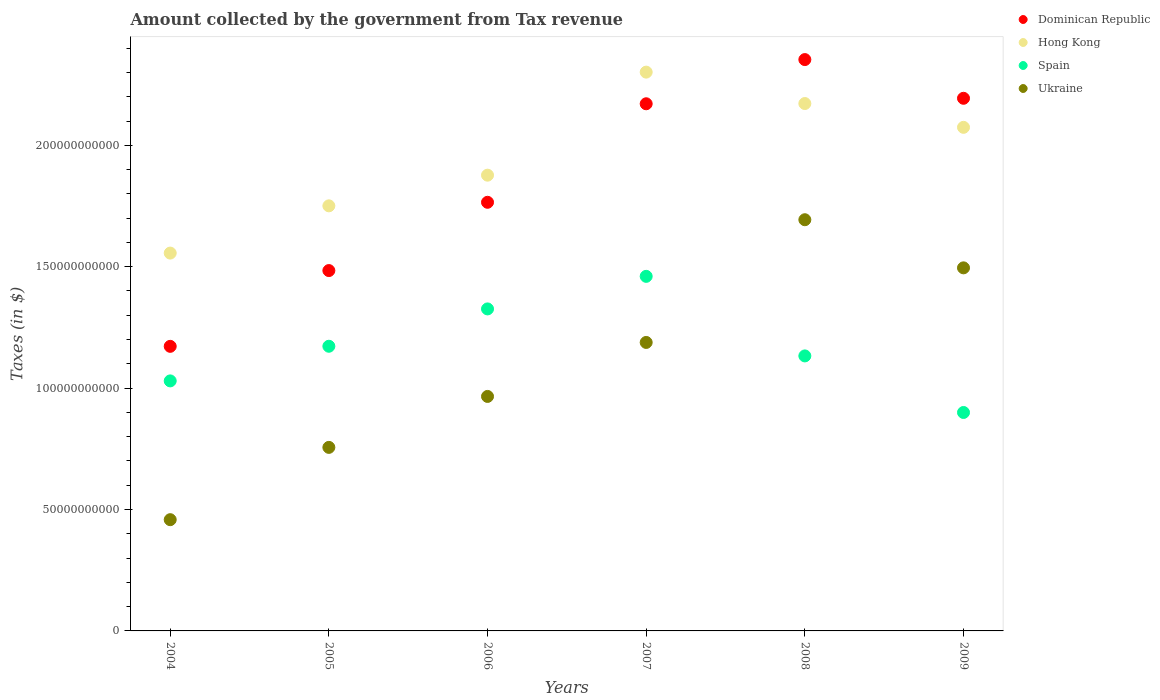How many different coloured dotlines are there?
Give a very brief answer. 4. Is the number of dotlines equal to the number of legend labels?
Your answer should be very brief. Yes. What is the amount collected by the government from tax revenue in Ukraine in 2004?
Give a very brief answer. 4.58e+1. Across all years, what is the maximum amount collected by the government from tax revenue in Ukraine?
Provide a short and direct response. 1.69e+11. Across all years, what is the minimum amount collected by the government from tax revenue in Hong Kong?
Ensure brevity in your answer.  1.56e+11. In which year was the amount collected by the government from tax revenue in Spain maximum?
Your response must be concise. 2007. In which year was the amount collected by the government from tax revenue in Spain minimum?
Provide a short and direct response. 2009. What is the total amount collected by the government from tax revenue in Dominican Republic in the graph?
Keep it short and to the point. 1.11e+12. What is the difference between the amount collected by the government from tax revenue in Hong Kong in 2005 and that in 2007?
Provide a short and direct response. -5.51e+1. What is the difference between the amount collected by the government from tax revenue in Spain in 2004 and the amount collected by the government from tax revenue in Dominican Republic in 2005?
Your answer should be compact. -4.54e+1. What is the average amount collected by the government from tax revenue in Ukraine per year?
Give a very brief answer. 1.09e+11. In the year 2008, what is the difference between the amount collected by the government from tax revenue in Hong Kong and amount collected by the government from tax revenue in Spain?
Keep it short and to the point. 1.04e+11. What is the ratio of the amount collected by the government from tax revenue in Spain in 2005 to that in 2009?
Give a very brief answer. 1.3. Is the difference between the amount collected by the government from tax revenue in Hong Kong in 2004 and 2005 greater than the difference between the amount collected by the government from tax revenue in Spain in 2004 and 2005?
Ensure brevity in your answer.  No. What is the difference between the highest and the second highest amount collected by the government from tax revenue in Hong Kong?
Offer a terse response. 1.29e+1. What is the difference between the highest and the lowest amount collected by the government from tax revenue in Hong Kong?
Offer a very short reply. 7.45e+1. Does the amount collected by the government from tax revenue in Dominican Republic monotonically increase over the years?
Offer a very short reply. No. Is the amount collected by the government from tax revenue in Spain strictly greater than the amount collected by the government from tax revenue in Dominican Republic over the years?
Provide a short and direct response. No. How many dotlines are there?
Keep it short and to the point. 4. Does the graph contain any zero values?
Keep it short and to the point. No. Where does the legend appear in the graph?
Ensure brevity in your answer.  Top right. How are the legend labels stacked?
Ensure brevity in your answer.  Vertical. What is the title of the graph?
Provide a short and direct response. Amount collected by the government from Tax revenue. What is the label or title of the Y-axis?
Your answer should be very brief. Taxes (in $). What is the Taxes (in $) of Dominican Republic in 2004?
Ensure brevity in your answer.  1.17e+11. What is the Taxes (in $) in Hong Kong in 2004?
Keep it short and to the point. 1.56e+11. What is the Taxes (in $) of Spain in 2004?
Your response must be concise. 1.03e+11. What is the Taxes (in $) in Ukraine in 2004?
Give a very brief answer. 4.58e+1. What is the Taxes (in $) of Dominican Republic in 2005?
Keep it short and to the point. 1.48e+11. What is the Taxes (in $) in Hong Kong in 2005?
Offer a terse response. 1.75e+11. What is the Taxes (in $) of Spain in 2005?
Provide a short and direct response. 1.17e+11. What is the Taxes (in $) in Ukraine in 2005?
Your answer should be compact. 7.56e+1. What is the Taxes (in $) of Dominican Republic in 2006?
Your response must be concise. 1.77e+11. What is the Taxes (in $) in Hong Kong in 2006?
Ensure brevity in your answer.  1.88e+11. What is the Taxes (in $) in Spain in 2006?
Offer a terse response. 1.33e+11. What is the Taxes (in $) of Ukraine in 2006?
Your answer should be very brief. 9.66e+1. What is the Taxes (in $) of Dominican Republic in 2007?
Give a very brief answer. 2.17e+11. What is the Taxes (in $) of Hong Kong in 2007?
Offer a terse response. 2.30e+11. What is the Taxes (in $) of Spain in 2007?
Offer a very short reply. 1.46e+11. What is the Taxes (in $) in Ukraine in 2007?
Offer a terse response. 1.19e+11. What is the Taxes (in $) in Dominican Republic in 2008?
Make the answer very short. 2.35e+11. What is the Taxes (in $) in Hong Kong in 2008?
Ensure brevity in your answer.  2.17e+11. What is the Taxes (in $) in Spain in 2008?
Your answer should be compact. 1.13e+11. What is the Taxes (in $) of Ukraine in 2008?
Give a very brief answer. 1.69e+11. What is the Taxes (in $) of Dominican Republic in 2009?
Your response must be concise. 2.19e+11. What is the Taxes (in $) in Hong Kong in 2009?
Keep it short and to the point. 2.07e+11. What is the Taxes (in $) of Spain in 2009?
Ensure brevity in your answer.  9.00e+1. What is the Taxes (in $) of Ukraine in 2009?
Ensure brevity in your answer.  1.50e+11. Across all years, what is the maximum Taxes (in $) in Dominican Republic?
Your response must be concise. 2.35e+11. Across all years, what is the maximum Taxes (in $) of Hong Kong?
Your response must be concise. 2.30e+11. Across all years, what is the maximum Taxes (in $) in Spain?
Your answer should be compact. 1.46e+11. Across all years, what is the maximum Taxes (in $) of Ukraine?
Provide a succinct answer. 1.69e+11. Across all years, what is the minimum Taxes (in $) of Dominican Republic?
Make the answer very short. 1.17e+11. Across all years, what is the minimum Taxes (in $) of Hong Kong?
Provide a succinct answer. 1.56e+11. Across all years, what is the minimum Taxes (in $) of Spain?
Keep it short and to the point. 9.00e+1. Across all years, what is the minimum Taxes (in $) of Ukraine?
Offer a very short reply. 4.58e+1. What is the total Taxes (in $) in Dominican Republic in the graph?
Provide a short and direct response. 1.11e+12. What is the total Taxes (in $) in Hong Kong in the graph?
Offer a terse response. 1.17e+12. What is the total Taxes (in $) in Spain in the graph?
Keep it short and to the point. 7.02e+11. What is the total Taxes (in $) of Ukraine in the graph?
Offer a very short reply. 6.56e+11. What is the difference between the Taxes (in $) in Dominican Republic in 2004 and that in 2005?
Ensure brevity in your answer.  -3.12e+1. What is the difference between the Taxes (in $) of Hong Kong in 2004 and that in 2005?
Give a very brief answer. -1.95e+1. What is the difference between the Taxes (in $) of Spain in 2004 and that in 2005?
Provide a short and direct response. -1.43e+1. What is the difference between the Taxes (in $) in Ukraine in 2004 and that in 2005?
Offer a very short reply. -2.98e+1. What is the difference between the Taxes (in $) in Dominican Republic in 2004 and that in 2006?
Make the answer very short. -5.93e+1. What is the difference between the Taxes (in $) of Hong Kong in 2004 and that in 2006?
Provide a succinct answer. -3.21e+1. What is the difference between the Taxes (in $) in Spain in 2004 and that in 2006?
Give a very brief answer. -2.96e+1. What is the difference between the Taxes (in $) in Ukraine in 2004 and that in 2006?
Offer a terse response. -5.08e+1. What is the difference between the Taxes (in $) in Dominican Republic in 2004 and that in 2007?
Provide a succinct answer. -9.99e+1. What is the difference between the Taxes (in $) of Hong Kong in 2004 and that in 2007?
Offer a terse response. -7.45e+1. What is the difference between the Taxes (in $) in Spain in 2004 and that in 2007?
Offer a very short reply. -4.31e+1. What is the difference between the Taxes (in $) of Ukraine in 2004 and that in 2007?
Your response must be concise. -7.30e+1. What is the difference between the Taxes (in $) in Dominican Republic in 2004 and that in 2008?
Provide a succinct answer. -1.18e+11. What is the difference between the Taxes (in $) in Hong Kong in 2004 and that in 2008?
Give a very brief answer. -6.16e+1. What is the difference between the Taxes (in $) of Spain in 2004 and that in 2008?
Your response must be concise. -1.03e+1. What is the difference between the Taxes (in $) in Ukraine in 2004 and that in 2008?
Your answer should be very brief. -1.24e+11. What is the difference between the Taxes (in $) of Dominican Republic in 2004 and that in 2009?
Ensure brevity in your answer.  -1.02e+11. What is the difference between the Taxes (in $) of Hong Kong in 2004 and that in 2009?
Your answer should be compact. -5.18e+1. What is the difference between the Taxes (in $) in Spain in 2004 and that in 2009?
Your answer should be compact. 1.30e+1. What is the difference between the Taxes (in $) in Ukraine in 2004 and that in 2009?
Keep it short and to the point. -1.04e+11. What is the difference between the Taxes (in $) of Dominican Republic in 2005 and that in 2006?
Offer a very short reply. -2.81e+1. What is the difference between the Taxes (in $) in Hong Kong in 2005 and that in 2006?
Make the answer very short. -1.26e+1. What is the difference between the Taxes (in $) of Spain in 2005 and that in 2006?
Provide a short and direct response. -1.54e+1. What is the difference between the Taxes (in $) in Ukraine in 2005 and that in 2006?
Offer a very short reply. -2.10e+1. What is the difference between the Taxes (in $) of Dominican Republic in 2005 and that in 2007?
Your response must be concise. -6.87e+1. What is the difference between the Taxes (in $) in Hong Kong in 2005 and that in 2007?
Give a very brief answer. -5.51e+1. What is the difference between the Taxes (in $) of Spain in 2005 and that in 2007?
Ensure brevity in your answer.  -2.88e+1. What is the difference between the Taxes (in $) in Ukraine in 2005 and that in 2007?
Ensure brevity in your answer.  -4.32e+1. What is the difference between the Taxes (in $) of Dominican Republic in 2005 and that in 2008?
Offer a terse response. -8.69e+1. What is the difference between the Taxes (in $) of Hong Kong in 2005 and that in 2008?
Offer a terse response. -4.21e+1. What is the difference between the Taxes (in $) of Spain in 2005 and that in 2008?
Provide a short and direct response. 3.98e+09. What is the difference between the Taxes (in $) of Ukraine in 2005 and that in 2008?
Your answer should be compact. -9.38e+1. What is the difference between the Taxes (in $) of Dominican Republic in 2005 and that in 2009?
Ensure brevity in your answer.  -7.10e+1. What is the difference between the Taxes (in $) in Hong Kong in 2005 and that in 2009?
Make the answer very short. -3.23e+1. What is the difference between the Taxes (in $) of Spain in 2005 and that in 2009?
Give a very brief answer. 2.73e+1. What is the difference between the Taxes (in $) in Ukraine in 2005 and that in 2009?
Offer a very short reply. -7.39e+1. What is the difference between the Taxes (in $) of Dominican Republic in 2006 and that in 2007?
Give a very brief answer. -4.06e+1. What is the difference between the Taxes (in $) in Hong Kong in 2006 and that in 2007?
Offer a terse response. -4.24e+1. What is the difference between the Taxes (in $) in Spain in 2006 and that in 2007?
Your answer should be very brief. -1.34e+1. What is the difference between the Taxes (in $) of Ukraine in 2006 and that in 2007?
Make the answer very short. -2.22e+1. What is the difference between the Taxes (in $) of Dominican Republic in 2006 and that in 2008?
Provide a short and direct response. -5.88e+1. What is the difference between the Taxes (in $) of Hong Kong in 2006 and that in 2008?
Your answer should be compact. -2.95e+1. What is the difference between the Taxes (in $) of Spain in 2006 and that in 2008?
Provide a short and direct response. 1.94e+1. What is the difference between the Taxes (in $) in Ukraine in 2006 and that in 2008?
Your answer should be compact. -7.28e+1. What is the difference between the Taxes (in $) of Dominican Republic in 2006 and that in 2009?
Offer a very short reply. -4.28e+1. What is the difference between the Taxes (in $) of Hong Kong in 2006 and that in 2009?
Your answer should be compact. -1.97e+1. What is the difference between the Taxes (in $) in Spain in 2006 and that in 2009?
Keep it short and to the point. 4.27e+1. What is the difference between the Taxes (in $) of Ukraine in 2006 and that in 2009?
Your answer should be very brief. -5.30e+1. What is the difference between the Taxes (in $) of Dominican Republic in 2007 and that in 2008?
Your response must be concise. -1.82e+1. What is the difference between the Taxes (in $) in Hong Kong in 2007 and that in 2008?
Offer a terse response. 1.29e+1. What is the difference between the Taxes (in $) of Spain in 2007 and that in 2008?
Offer a terse response. 3.28e+1. What is the difference between the Taxes (in $) in Ukraine in 2007 and that in 2008?
Your answer should be very brief. -5.05e+1. What is the difference between the Taxes (in $) of Dominican Republic in 2007 and that in 2009?
Give a very brief answer. -2.26e+09. What is the difference between the Taxes (in $) in Hong Kong in 2007 and that in 2009?
Offer a very short reply. 2.27e+1. What is the difference between the Taxes (in $) in Spain in 2007 and that in 2009?
Provide a short and direct response. 5.61e+1. What is the difference between the Taxes (in $) in Ukraine in 2007 and that in 2009?
Make the answer very short. -3.07e+1. What is the difference between the Taxes (in $) in Dominican Republic in 2008 and that in 2009?
Your answer should be very brief. 1.59e+1. What is the difference between the Taxes (in $) in Hong Kong in 2008 and that in 2009?
Keep it short and to the point. 9.80e+09. What is the difference between the Taxes (in $) of Spain in 2008 and that in 2009?
Offer a terse response. 2.33e+1. What is the difference between the Taxes (in $) of Ukraine in 2008 and that in 2009?
Make the answer very short. 1.98e+1. What is the difference between the Taxes (in $) in Dominican Republic in 2004 and the Taxes (in $) in Hong Kong in 2005?
Your answer should be very brief. -5.79e+1. What is the difference between the Taxes (in $) in Dominican Republic in 2004 and the Taxes (in $) in Spain in 2005?
Your response must be concise. -3.61e+07. What is the difference between the Taxes (in $) of Dominican Republic in 2004 and the Taxes (in $) of Ukraine in 2005?
Your answer should be very brief. 4.16e+1. What is the difference between the Taxes (in $) of Hong Kong in 2004 and the Taxes (in $) of Spain in 2005?
Offer a very short reply. 3.84e+1. What is the difference between the Taxes (in $) of Hong Kong in 2004 and the Taxes (in $) of Ukraine in 2005?
Ensure brevity in your answer.  8.00e+1. What is the difference between the Taxes (in $) in Spain in 2004 and the Taxes (in $) in Ukraine in 2005?
Keep it short and to the point. 2.74e+1. What is the difference between the Taxes (in $) of Dominican Republic in 2004 and the Taxes (in $) of Hong Kong in 2006?
Offer a terse response. -7.05e+1. What is the difference between the Taxes (in $) of Dominican Republic in 2004 and the Taxes (in $) of Spain in 2006?
Your answer should be compact. -1.54e+1. What is the difference between the Taxes (in $) in Dominican Republic in 2004 and the Taxes (in $) in Ukraine in 2006?
Your answer should be compact. 2.06e+1. What is the difference between the Taxes (in $) of Hong Kong in 2004 and the Taxes (in $) of Spain in 2006?
Keep it short and to the point. 2.30e+1. What is the difference between the Taxes (in $) in Hong Kong in 2004 and the Taxes (in $) in Ukraine in 2006?
Provide a succinct answer. 5.90e+1. What is the difference between the Taxes (in $) of Spain in 2004 and the Taxes (in $) of Ukraine in 2006?
Ensure brevity in your answer.  6.40e+09. What is the difference between the Taxes (in $) in Dominican Republic in 2004 and the Taxes (in $) in Hong Kong in 2007?
Ensure brevity in your answer.  -1.13e+11. What is the difference between the Taxes (in $) of Dominican Republic in 2004 and the Taxes (in $) of Spain in 2007?
Ensure brevity in your answer.  -2.88e+1. What is the difference between the Taxes (in $) of Dominican Republic in 2004 and the Taxes (in $) of Ukraine in 2007?
Keep it short and to the point. -1.61e+09. What is the difference between the Taxes (in $) in Hong Kong in 2004 and the Taxes (in $) in Spain in 2007?
Your answer should be very brief. 9.58e+09. What is the difference between the Taxes (in $) of Hong Kong in 2004 and the Taxes (in $) of Ukraine in 2007?
Ensure brevity in your answer.  3.68e+1. What is the difference between the Taxes (in $) in Spain in 2004 and the Taxes (in $) in Ukraine in 2007?
Ensure brevity in your answer.  -1.58e+1. What is the difference between the Taxes (in $) of Dominican Republic in 2004 and the Taxes (in $) of Hong Kong in 2008?
Make the answer very short. -1.00e+11. What is the difference between the Taxes (in $) of Dominican Republic in 2004 and the Taxes (in $) of Spain in 2008?
Your answer should be very brief. 3.94e+09. What is the difference between the Taxes (in $) in Dominican Republic in 2004 and the Taxes (in $) in Ukraine in 2008?
Keep it short and to the point. -5.21e+1. What is the difference between the Taxes (in $) in Hong Kong in 2004 and the Taxes (in $) in Spain in 2008?
Your answer should be compact. 4.23e+1. What is the difference between the Taxes (in $) of Hong Kong in 2004 and the Taxes (in $) of Ukraine in 2008?
Offer a terse response. -1.37e+1. What is the difference between the Taxes (in $) in Spain in 2004 and the Taxes (in $) in Ukraine in 2008?
Your response must be concise. -6.64e+1. What is the difference between the Taxes (in $) of Dominican Republic in 2004 and the Taxes (in $) of Hong Kong in 2009?
Your response must be concise. -9.02e+1. What is the difference between the Taxes (in $) of Dominican Republic in 2004 and the Taxes (in $) of Spain in 2009?
Keep it short and to the point. 2.72e+1. What is the difference between the Taxes (in $) in Dominican Republic in 2004 and the Taxes (in $) in Ukraine in 2009?
Offer a very short reply. -3.23e+1. What is the difference between the Taxes (in $) of Hong Kong in 2004 and the Taxes (in $) of Spain in 2009?
Your answer should be compact. 6.56e+1. What is the difference between the Taxes (in $) in Hong Kong in 2004 and the Taxes (in $) in Ukraine in 2009?
Give a very brief answer. 6.08e+09. What is the difference between the Taxes (in $) of Spain in 2004 and the Taxes (in $) of Ukraine in 2009?
Your response must be concise. -4.66e+1. What is the difference between the Taxes (in $) of Dominican Republic in 2005 and the Taxes (in $) of Hong Kong in 2006?
Provide a short and direct response. -3.93e+1. What is the difference between the Taxes (in $) of Dominican Republic in 2005 and the Taxes (in $) of Spain in 2006?
Offer a terse response. 1.58e+1. What is the difference between the Taxes (in $) of Dominican Republic in 2005 and the Taxes (in $) of Ukraine in 2006?
Ensure brevity in your answer.  5.18e+1. What is the difference between the Taxes (in $) in Hong Kong in 2005 and the Taxes (in $) in Spain in 2006?
Your answer should be compact. 4.25e+1. What is the difference between the Taxes (in $) of Hong Kong in 2005 and the Taxes (in $) of Ukraine in 2006?
Keep it short and to the point. 7.85e+1. What is the difference between the Taxes (in $) of Spain in 2005 and the Taxes (in $) of Ukraine in 2006?
Offer a terse response. 2.07e+1. What is the difference between the Taxes (in $) of Dominican Republic in 2005 and the Taxes (in $) of Hong Kong in 2007?
Provide a succinct answer. -8.17e+1. What is the difference between the Taxes (in $) of Dominican Republic in 2005 and the Taxes (in $) of Spain in 2007?
Offer a terse response. 2.38e+09. What is the difference between the Taxes (in $) in Dominican Republic in 2005 and the Taxes (in $) in Ukraine in 2007?
Make the answer very short. 2.96e+1. What is the difference between the Taxes (in $) of Hong Kong in 2005 and the Taxes (in $) of Spain in 2007?
Keep it short and to the point. 2.90e+1. What is the difference between the Taxes (in $) in Hong Kong in 2005 and the Taxes (in $) in Ukraine in 2007?
Offer a terse response. 5.63e+1. What is the difference between the Taxes (in $) of Spain in 2005 and the Taxes (in $) of Ukraine in 2007?
Keep it short and to the point. -1.57e+09. What is the difference between the Taxes (in $) in Dominican Republic in 2005 and the Taxes (in $) in Hong Kong in 2008?
Offer a very short reply. -6.88e+1. What is the difference between the Taxes (in $) of Dominican Republic in 2005 and the Taxes (in $) of Spain in 2008?
Make the answer very short. 3.52e+1. What is the difference between the Taxes (in $) of Dominican Republic in 2005 and the Taxes (in $) of Ukraine in 2008?
Ensure brevity in your answer.  -2.09e+1. What is the difference between the Taxes (in $) in Hong Kong in 2005 and the Taxes (in $) in Spain in 2008?
Make the answer very short. 6.18e+1. What is the difference between the Taxes (in $) of Hong Kong in 2005 and the Taxes (in $) of Ukraine in 2008?
Your answer should be very brief. 5.72e+09. What is the difference between the Taxes (in $) of Spain in 2005 and the Taxes (in $) of Ukraine in 2008?
Your answer should be compact. -5.21e+1. What is the difference between the Taxes (in $) of Dominican Republic in 2005 and the Taxes (in $) of Hong Kong in 2009?
Make the answer very short. -5.90e+1. What is the difference between the Taxes (in $) of Dominican Republic in 2005 and the Taxes (in $) of Spain in 2009?
Your response must be concise. 5.84e+1. What is the difference between the Taxes (in $) of Dominican Republic in 2005 and the Taxes (in $) of Ukraine in 2009?
Your answer should be compact. -1.12e+09. What is the difference between the Taxes (in $) in Hong Kong in 2005 and the Taxes (in $) in Spain in 2009?
Keep it short and to the point. 8.51e+1. What is the difference between the Taxes (in $) in Hong Kong in 2005 and the Taxes (in $) in Ukraine in 2009?
Provide a succinct answer. 2.55e+1. What is the difference between the Taxes (in $) in Spain in 2005 and the Taxes (in $) in Ukraine in 2009?
Your answer should be very brief. -3.23e+1. What is the difference between the Taxes (in $) in Dominican Republic in 2006 and the Taxes (in $) in Hong Kong in 2007?
Your answer should be compact. -5.36e+1. What is the difference between the Taxes (in $) of Dominican Republic in 2006 and the Taxes (in $) of Spain in 2007?
Provide a succinct answer. 3.05e+1. What is the difference between the Taxes (in $) in Dominican Republic in 2006 and the Taxes (in $) in Ukraine in 2007?
Your answer should be compact. 5.77e+1. What is the difference between the Taxes (in $) in Hong Kong in 2006 and the Taxes (in $) in Spain in 2007?
Offer a very short reply. 4.17e+1. What is the difference between the Taxes (in $) in Hong Kong in 2006 and the Taxes (in $) in Ukraine in 2007?
Offer a terse response. 6.89e+1. What is the difference between the Taxes (in $) in Spain in 2006 and the Taxes (in $) in Ukraine in 2007?
Your answer should be compact. 1.38e+1. What is the difference between the Taxes (in $) of Dominican Republic in 2006 and the Taxes (in $) of Hong Kong in 2008?
Provide a short and direct response. -4.07e+1. What is the difference between the Taxes (in $) of Dominican Republic in 2006 and the Taxes (in $) of Spain in 2008?
Your response must be concise. 6.33e+1. What is the difference between the Taxes (in $) of Dominican Republic in 2006 and the Taxes (in $) of Ukraine in 2008?
Give a very brief answer. 7.18e+09. What is the difference between the Taxes (in $) in Hong Kong in 2006 and the Taxes (in $) in Spain in 2008?
Your response must be concise. 7.44e+1. What is the difference between the Taxes (in $) of Hong Kong in 2006 and the Taxes (in $) of Ukraine in 2008?
Offer a very short reply. 1.84e+1. What is the difference between the Taxes (in $) in Spain in 2006 and the Taxes (in $) in Ukraine in 2008?
Provide a succinct answer. -3.67e+1. What is the difference between the Taxes (in $) in Dominican Republic in 2006 and the Taxes (in $) in Hong Kong in 2009?
Your response must be concise. -3.09e+1. What is the difference between the Taxes (in $) in Dominican Republic in 2006 and the Taxes (in $) in Spain in 2009?
Ensure brevity in your answer.  8.66e+1. What is the difference between the Taxes (in $) of Dominican Republic in 2006 and the Taxes (in $) of Ukraine in 2009?
Keep it short and to the point. 2.70e+1. What is the difference between the Taxes (in $) of Hong Kong in 2006 and the Taxes (in $) of Spain in 2009?
Give a very brief answer. 9.77e+1. What is the difference between the Taxes (in $) in Hong Kong in 2006 and the Taxes (in $) in Ukraine in 2009?
Provide a succinct answer. 3.82e+1. What is the difference between the Taxes (in $) in Spain in 2006 and the Taxes (in $) in Ukraine in 2009?
Ensure brevity in your answer.  -1.69e+1. What is the difference between the Taxes (in $) in Dominican Republic in 2007 and the Taxes (in $) in Hong Kong in 2008?
Ensure brevity in your answer.  -9.72e+07. What is the difference between the Taxes (in $) in Dominican Republic in 2007 and the Taxes (in $) in Spain in 2008?
Your response must be concise. 1.04e+11. What is the difference between the Taxes (in $) in Dominican Republic in 2007 and the Taxes (in $) in Ukraine in 2008?
Give a very brief answer. 4.78e+1. What is the difference between the Taxes (in $) of Hong Kong in 2007 and the Taxes (in $) of Spain in 2008?
Ensure brevity in your answer.  1.17e+11. What is the difference between the Taxes (in $) of Hong Kong in 2007 and the Taxes (in $) of Ukraine in 2008?
Make the answer very short. 6.08e+1. What is the difference between the Taxes (in $) of Spain in 2007 and the Taxes (in $) of Ukraine in 2008?
Provide a short and direct response. -2.33e+1. What is the difference between the Taxes (in $) of Dominican Republic in 2007 and the Taxes (in $) of Hong Kong in 2009?
Your answer should be very brief. 9.70e+09. What is the difference between the Taxes (in $) in Dominican Republic in 2007 and the Taxes (in $) in Spain in 2009?
Your answer should be very brief. 1.27e+11. What is the difference between the Taxes (in $) in Dominican Republic in 2007 and the Taxes (in $) in Ukraine in 2009?
Your response must be concise. 6.76e+1. What is the difference between the Taxes (in $) of Hong Kong in 2007 and the Taxes (in $) of Spain in 2009?
Your answer should be compact. 1.40e+11. What is the difference between the Taxes (in $) in Hong Kong in 2007 and the Taxes (in $) in Ukraine in 2009?
Give a very brief answer. 8.06e+1. What is the difference between the Taxes (in $) of Spain in 2007 and the Taxes (in $) of Ukraine in 2009?
Your answer should be very brief. -3.50e+09. What is the difference between the Taxes (in $) of Dominican Republic in 2008 and the Taxes (in $) of Hong Kong in 2009?
Give a very brief answer. 2.79e+1. What is the difference between the Taxes (in $) in Dominican Republic in 2008 and the Taxes (in $) in Spain in 2009?
Your answer should be compact. 1.45e+11. What is the difference between the Taxes (in $) in Dominican Republic in 2008 and the Taxes (in $) in Ukraine in 2009?
Your answer should be very brief. 8.58e+1. What is the difference between the Taxes (in $) of Hong Kong in 2008 and the Taxes (in $) of Spain in 2009?
Offer a terse response. 1.27e+11. What is the difference between the Taxes (in $) in Hong Kong in 2008 and the Taxes (in $) in Ukraine in 2009?
Your response must be concise. 6.77e+1. What is the difference between the Taxes (in $) in Spain in 2008 and the Taxes (in $) in Ukraine in 2009?
Offer a terse response. -3.63e+1. What is the average Taxes (in $) of Dominican Republic per year?
Your answer should be compact. 1.86e+11. What is the average Taxes (in $) of Hong Kong per year?
Your answer should be very brief. 1.96e+11. What is the average Taxes (in $) of Spain per year?
Give a very brief answer. 1.17e+11. What is the average Taxes (in $) in Ukraine per year?
Make the answer very short. 1.09e+11. In the year 2004, what is the difference between the Taxes (in $) of Dominican Republic and Taxes (in $) of Hong Kong?
Ensure brevity in your answer.  -3.84e+1. In the year 2004, what is the difference between the Taxes (in $) of Dominican Republic and Taxes (in $) of Spain?
Give a very brief answer. 1.42e+1. In the year 2004, what is the difference between the Taxes (in $) in Dominican Republic and Taxes (in $) in Ukraine?
Provide a short and direct response. 7.14e+1. In the year 2004, what is the difference between the Taxes (in $) of Hong Kong and Taxes (in $) of Spain?
Your answer should be compact. 5.26e+1. In the year 2004, what is the difference between the Taxes (in $) in Hong Kong and Taxes (in $) in Ukraine?
Provide a short and direct response. 1.10e+11. In the year 2004, what is the difference between the Taxes (in $) in Spain and Taxes (in $) in Ukraine?
Your answer should be very brief. 5.72e+1. In the year 2005, what is the difference between the Taxes (in $) in Dominican Republic and Taxes (in $) in Hong Kong?
Your answer should be compact. -2.67e+1. In the year 2005, what is the difference between the Taxes (in $) of Dominican Republic and Taxes (in $) of Spain?
Keep it short and to the point. 3.12e+1. In the year 2005, what is the difference between the Taxes (in $) in Dominican Republic and Taxes (in $) in Ukraine?
Ensure brevity in your answer.  7.28e+1. In the year 2005, what is the difference between the Taxes (in $) of Hong Kong and Taxes (in $) of Spain?
Your response must be concise. 5.78e+1. In the year 2005, what is the difference between the Taxes (in $) of Hong Kong and Taxes (in $) of Ukraine?
Offer a very short reply. 9.95e+1. In the year 2005, what is the difference between the Taxes (in $) of Spain and Taxes (in $) of Ukraine?
Ensure brevity in your answer.  4.16e+1. In the year 2006, what is the difference between the Taxes (in $) in Dominican Republic and Taxes (in $) in Hong Kong?
Your response must be concise. -1.12e+1. In the year 2006, what is the difference between the Taxes (in $) in Dominican Republic and Taxes (in $) in Spain?
Your answer should be compact. 4.39e+1. In the year 2006, what is the difference between the Taxes (in $) in Dominican Republic and Taxes (in $) in Ukraine?
Your answer should be compact. 8.00e+1. In the year 2006, what is the difference between the Taxes (in $) in Hong Kong and Taxes (in $) in Spain?
Offer a very short reply. 5.51e+1. In the year 2006, what is the difference between the Taxes (in $) of Hong Kong and Taxes (in $) of Ukraine?
Give a very brief answer. 9.11e+1. In the year 2006, what is the difference between the Taxes (in $) in Spain and Taxes (in $) in Ukraine?
Make the answer very short. 3.60e+1. In the year 2007, what is the difference between the Taxes (in $) in Dominican Republic and Taxes (in $) in Hong Kong?
Your response must be concise. -1.30e+1. In the year 2007, what is the difference between the Taxes (in $) in Dominican Republic and Taxes (in $) in Spain?
Keep it short and to the point. 7.11e+1. In the year 2007, what is the difference between the Taxes (in $) of Dominican Republic and Taxes (in $) of Ukraine?
Make the answer very short. 9.83e+1. In the year 2007, what is the difference between the Taxes (in $) in Hong Kong and Taxes (in $) in Spain?
Keep it short and to the point. 8.41e+1. In the year 2007, what is the difference between the Taxes (in $) of Hong Kong and Taxes (in $) of Ukraine?
Keep it short and to the point. 1.11e+11. In the year 2007, what is the difference between the Taxes (in $) in Spain and Taxes (in $) in Ukraine?
Make the answer very short. 2.72e+1. In the year 2008, what is the difference between the Taxes (in $) of Dominican Republic and Taxes (in $) of Hong Kong?
Offer a terse response. 1.81e+1. In the year 2008, what is the difference between the Taxes (in $) of Dominican Republic and Taxes (in $) of Spain?
Make the answer very short. 1.22e+11. In the year 2008, what is the difference between the Taxes (in $) of Dominican Republic and Taxes (in $) of Ukraine?
Provide a short and direct response. 6.60e+1. In the year 2008, what is the difference between the Taxes (in $) of Hong Kong and Taxes (in $) of Spain?
Offer a very short reply. 1.04e+11. In the year 2008, what is the difference between the Taxes (in $) of Hong Kong and Taxes (in $) of Ukraine?
Provide a short and direct response. 4.79e+1. In the year 2008, what is the difference between the Taxes (in $) in Spain and Taxes (in $) in Ukraine?
Make the answer very short. -5.61e+1. In the year 2009, what is the difference between the Taxes (in $) in Dominican Republic and Taxes (in $) in Hong Kong?
Give a very brief answer. 1.20e+1. In the year 2009, what is the difference between the Taxes (in $) in Dominican Republic and Taxes (in $) in Spain?
Provide a succinct answer. 1.29e+11. In the year 2009, what is the difference between the Taxes (in $) in Dominican Republic and Taxes (in $) in Ukraine?
Your answer should be very brief. 6.98e+1. In the year 2009, what is the difference between the Taxes (in $) in Hong Kong and Taxes (in $) in Spain?
Provide a short and direct response. 1.17e+11. In the year 2009, what is the difference between the Taxes (in $) of Hong Kong and Taxes (in $) of Ukraine?
Offer a terse response. 5.79e+1. In the year 2009, what is the difference between the Taxes (in $) in Spain and Taxes (in $) in Ukraine?
Offer a terse response. -5.96e+1. What is the ratio of the Taxes (in $) in Dominican Republic in 2004 to that in 2005?
Offer a terse response. 0.79. What is the ratio of the Taxes (in $) in Hong Kong in 2004 to that in 2005?
Provide a short and direct response. 0.89. What is the ratio of the Taxes (in $) of Spain in 2004 to that in 2005?
Make the answer very short. 0.88. What is the ratio of the Taxes (in $) of Ukraine in 2004 to that in 2005?
Provide a succinct answer. 0.61. What is the ratio of the Taxes (in $) of Dominican Republic in 2004 to that in 2006?
Offer a very short reply. 0.66. What is the ratio of the Taxes (in $) in Hong Kong in 2004 to that in 2006?
Give a very brief answer. 0.83. What is the ratio of the Taxes (in $) in Spain in 2004 to that in 2006?
Provide a short and direct response. 0.78. What is the ratio of the Taxes (in $) in Ukraine in 2004 to that in 2006?
Keep it short and to the point. 0.47. What is the ratio of the Taxes (in $) in Dominican Republic in 2004 to that in 2007?
Your answer should be very brief. 0.54. What is the ratio of the Taxes (in $) in Hong Kong in 2004 to that in 2007?
Offer a very short reply. 0.68. What is the ratio of the Taxes (in $) of Spain in 2004 to that in 2007?
Make the answer very short. 0.71. What is the ratio of the Taxes (in $) of Ukraine in 2004 to that in 2007?
Your answer should be very brief. 0.39. What is the ratio of the Taxes (in $) in Dominican Republic in 2004 to that in 2008?
Make the answer very short. 0.5. What is the ratio of the Taxes (in $) in Hong Kong in 2004 to that in 2008?
Give a very brief answer. 0.72. What is the ratio of the Taxes (in $) in Ukraine in 2004 to that in 2008?
Give a very brief answer. 0.27. What is the ratio of the Taxes (in $) of Dominican Republic in 2004 to that in 2009?
Ensure brevity in your answer.  0.53. What is the ratio of the Taxes (in $) in Hong Kong in 2004 to that in 2009?
Provide a short and direct response. 0.75. What is the ratio of the Taxes (in $) of Spain in 2004 to that in 2009?
Your response must be concise. 1.14. What is the ratio of the Taxes (in $) in Ukraine in 2004 to that in 2009?
Your answer should be compact. 0.31. What is the ratio of the Taxes (in $) of Dominican Republic in 2005 to that in 2006?
Provide a short and direct response. 0.84. What is the ratio of the Taxes (in $) of Hong Kong in 2005 to that in 2006?
Ensure brevity in your answer.  0.93. What is the ratio of the Taxes (in $) in Spain in 2005 to that in 2006?
Your answer should be very brief. 0.88. What is the ratio of the Taxes (in $) in Ukraine in 2005 to that in 2006?
Keep it short and to the point. 0.78. What is the ratio of the Taxes (in $) in Dominican Republic in 2005 to that in 2007?
Your answer should be compact. 0.68. What is the ratio of the Taxes (in $) in Hong Kong in 2005 to that in 2007?
Keep it short and to the point. 0.76. What is the ratio of the Taxes (in $) of Spain in 2005 to that in 2007?
Offer a terse response. 0.8. What is the ratio of the Taxes (in $) in Ukraine in 2005 to that in 2007?
Provide a succinct answer. 0.64. What is the ratio of the Taxes (in $) in Dominican Republic in 2005 to that in 2008?
Your answer should be very brief. 0.63. What is the ratio of the Taxes (in $) in Hong Kong in 2005 to that in 2008?
Your answer should be very brief. 0.81. What is the ratio of the Taxes (in $) of Spain in 2005 to that in 2008?
Your response must be concise. 1.04. What is the ratio of the Taxes (in $) in Ukraine in 2005 to that in 2008?
Make the answer very short. 0.45. What is the ratio of the Taxes (in $) in Dominican Republic in 2005 to that in 2009?
Keep it short and to the point. 0.68. What is the ratio of the Taxes (in $) of Hong Kong in 2005 to that in 2009?
Ensure brevity in your answer.  0.84. What is the ratio of the Taxes (in $) in Spain in 2005 to that in 2009?
Offer a terse response. 1.3. What is the ratio of the Taxes (in $) of Ukraine in 2005 to that in 2009?
Keep it short and to the point. 0.51. What is the ratio of the Taxes (in $) in Dominican Republic in 2006 to that in 2007?
Provide a short and direct response. 0.81. What is the ratio of the Taxes (in $) of Hong Kong in 2006 to that in 2007?
Keep it short and to the point. 0.82. What is the ratio of the Taxes (in $) of Spain in 2006 to that in 2007?
Ensure brevity in your answer.  0.91. What is the ratio of the Taxes (in $) in Ukraine in 2006 to that in 2007?
Provide a short and direct response. 0.81. What is the ratio of the Taxes (in $) in Dominican Republic in 2006 to that in 2008?
Provide a succinct answer. 0.75. What is the ratio of the Taxes (in $) of Hong Kong in 2006 to that in 2008?
Make the answer very short. 0.86. What is the ratio of the Taxes (in $) of Spain in 2006 to that in 2008?
Keep it short and to the point. 1.17. What is the ratio of the Taxes (in $) in Ukraine in 2006 to that in 2008?
Give a very brief answer. 0.57. What is the ratio of the Taxes (in $) of Dominican Republic in 2006 to that in 2009?
Your answer should be very brief. 0.8. What is the ratio of the Taxes (in $) of Hong Kong in 2006 to that in 2009?
Provide a short and direct response. 0.91. What is the ratio of the Taxes (in $) in Spain in 2006 to that in 2009?
Make the answer very short. 1.47. What is the ratio of the Taxes (in $) of Ukraine in 2006 to that in 2009?
Offer a very short reply. 0.65. What is the ratio of the Taxes (in $) in Dominican Republic in 2007 to that in 2008?
Give a very brief answer. 0.92. What is the ratio of the Taxes (in $) in Hong Kong in 2007 to that in 2008?
Keep it short and to the point. 1.06. What is the ratio of the Taxes (in $) in Spain in 2007 to that in 2008?
Your response must be concise. 1.29. What is the ratio of the Taxes (in $) in Ukraine in 2007 to that in 2008?
Provide a succinct answer. 0.7. What is the ratio of the Taxes (in $) of Dominican Republic in 2007 to that in 2009?
Provide a succinct answer. 0.99. What is the ratio of the Taxes (in $) of Hong Kong in 2007 to that in 2009?
Your response must be concise. 1.11. What is the ratio of the Taxes (in $) of Spain in 2007 to that in 2009?
Ensure brevity in your answer.  1.62. What is the ratio of the Taxes (in $) in Ukraine in 2007 to that in 2009?
Your response must be concise. 0.79. What is the ratio of the Taxes (in $) of Dominican Republic in 2008 to that in 2009?
Offer a very short reply. 1.07. What is the ratio of the Taxes (in $) in Hong Kong in 2008 to that in 2009?
Give a very brief answer. 1.05. What is the ratio of the Taxes (in $) in Spain in 2008 to that in 2009?
Your response must be concise. 1.26. What is the ratio of the Taxes (in $) of Ukraine in 2008 to that in 2009?
Provide a succinct answer. 1.13. What is the difference between the highest and the second highest Taxes (in $) in Dominican Republic?
Ensure brevity in your answer.  1.59e+1. What is the difference between the highest and the second highest Taxes (in $) of Hong Kong?
Give a very brief answer. 1.29e+1. What is the difference between the highest and the second highest Taxes (in $) of Spain?
Your answer should be compact. 1.34e+1. What is the difference between the highest and the second highest Taxes (in $) of Ukraine?
Offer a very short reply. 1.98e+1. What is the difference between the highest and the lowest Taxes (in $) of Dominican Republic?
Offer a very short reply. 1.18e+11. What is the difference between the highest and the lowest Taxes (in $) of Hong Kong?
Offer a very short reply. 7.45e+1. What is the difference between the highest and the lowest Taxes (in $) of Spain?
Ensure brevity in your answer.  5.61e+1. What is the difference between the highest and the lowest Taxes (in $) of Ukraine?
Keep it short and to the point. 1.24e+11. 